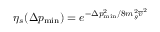Convert formula to latex. <formula><loc_0><loc_0><loc_500><loc_500>\eta _ { s } ( \Delta p _ { \min } ) = e ^ { - \Delta p _ { \min } ^ { 2 } / 8 m _ { g } ^ { 2 } \overline { v } ^ { 2 } }</formula> 